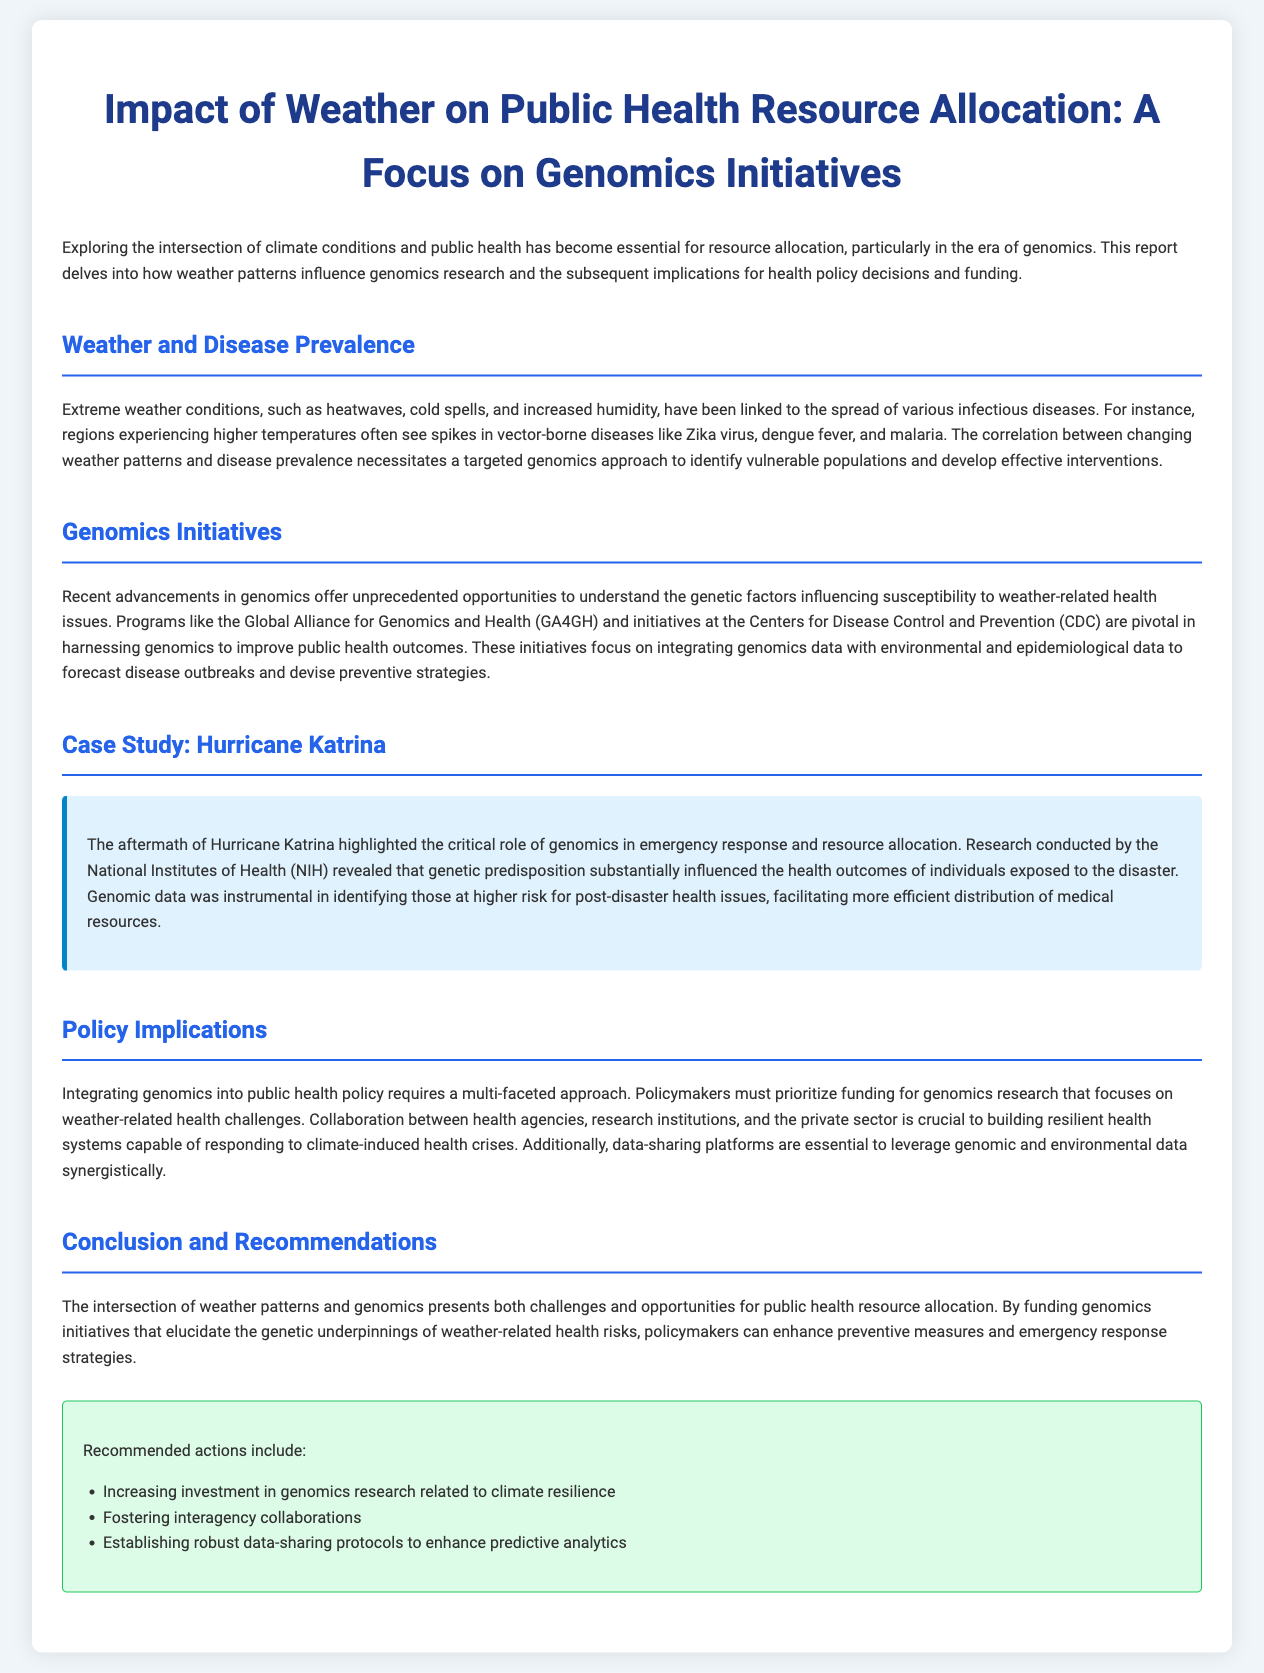What is the focus of the report? The report focuses on the intersection of climate conditions and public health, particularly in the realm of genomics.
Answer: Genomics Initiatives What organizations are mentioned in the genomics initiatives section? The section refers to the Global Alliance for Genomics and Health (GA4GH) and the Centers for Disease Control and Prevention (CDC).
Answer: GA4GH and CDC Which extreme weather condition is linked to vector-borne diseases? The document mentions that higher temperatures often correlate with the spread of vector-borne diseases.
Answer: Higher temperatures What case study is highlighted in the report? The case study discussed pertains to the impact of Hurricane Katrina on health outcomes.
Answer: Hurricane Katrina What is a recommended action for public health policy? The document suggests increasing investment in genomics research related to climate resilience as a recommended action.
Answer: Increasing investment in genomics research What health issue did Hurricane Katrina expose related to genetics? The report indicates that genetic predisposition influenced the health outcomes of individuals exposed to Hurricane Katrina.
Answer: Genetic predisposition How does the report suggest improving predictive analytics? It recommends establishing robust data-sharing protocols to enhance predictive analytics for public health.
Answer: Data-sharing protocols What is necessary for building resilient health systems according to the document? Collaboration between health agencies, research institutions, and the private sector is emphasized as crucial for building resilient health systems.
Answer: Collaboration What environmental data should be integrated with genomics data? The integration of environmental and epidemiological data with genomics data is important for forecasting disease outbreaks.
Answer: Environmental and epidemiological data 